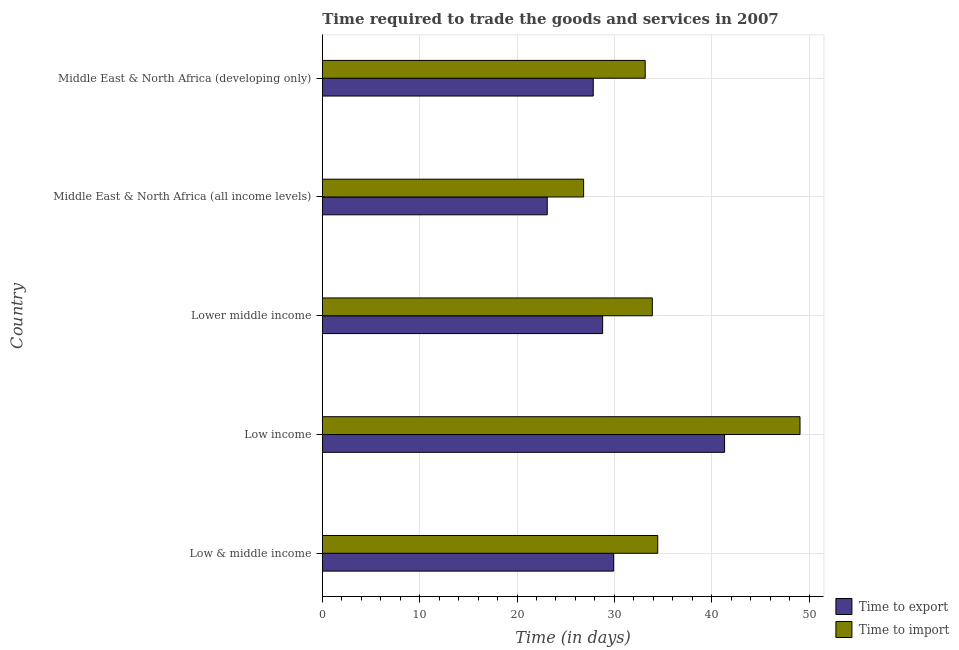How many different coloured bars are there?
Provide a succinct answer. 2. How many groups of bars are there?
Give a very brief answer. 5. Are the number of bars per tick equal to the number of legend labels?
Your response must be concise. Yes. Are the number of bars on each tick of the Y-axis equal?
Your answer should be compact. Yes. How many bars are there on the 3rd tick from the top?
Offer a very short reply. 2. How many bars are there on the 2nd tick from the bottom?
Keep it short and to the point. 2. What is the label of the 1st group of bars from the top?
Offer a terse response. Middle East & North Africa (developing only). What is the time to export in Middle East & North Africa (all income levels)?
Offer a very short reply. 23.11. Across all countries, what is the maximum time to export?
Make the answer very short. 41.32. Across all countries, what is the minimum time to import?
Provide a short and direct response. 26.84. In which country was the time to import maximum?
Offer a terse response. Low income. In which country was the time to export minimum?
Your response must be concise. Middle East & North Africa (all income levels). What is the total time to import in the graph?
Provide a succinct answer. 177.43. What is the difference between the time to import in Middle East & North Africa (all income levels) and that in Middle East & North Africa (developing only)?
Your response must be concise. -6.33. What is the difference between the time to import in Low income and the time to export in Middle East & North Africa (developing only)?
Provide a succinct answer. 21.24. What is the average time to import per country?
Make the answer very short. 35.49. What is the difference between the time to export and time to import in Lower middle income?
Offer a terse response. -5.1. In how many countries, is the time to export greater than 22 days?
Keep it short and to the point. 5. What is the ratio of the time to export in Low & middle income to that in Lower middle income?
Provide a succinct answer. 1.04. Is the difference between the time to export in Low & middle income and Middle East & North Africa (developing only) greater than the difference between the time to import in Low & middle income and Middle East & North Africa (developing only)?
Make the answer very short. Yes. What is the difference between the highest and the second highest time to export?
Offer a terse response. 11.39. What is the difference between the highest and the lowest time to export?
Ensure brevity in your answer.  18.22. Is the sum of the time to import in Low income and Middle East & North Africa (all income levels) greater than the maximum time to export across all countries?
Your answer should be compact. Yes. What does the 2nd bar from the top in Low income represents?
Provide a succinct answer. Time to export. What does the 2nd bar from the bottom in Low & middle income represents?
Offer a terse response. Time to import. How many bars are there?
Offer a very short reply. 10. Are all the bars in the graph horizontal?
Make the answer very short. Yes. What is the difference between two consecutive major ticks on the X-axis?
Offer a very short reply. 10. Does the graph contain any zero values?
Offer a terse response. No. Does the graph contain grids?
Your response must be concise. Yes. Where does the legend appear in the graph?
Offer a terse response. Bottom right. How many legend labels are there?
Your answer should be very brief. 2. What is the title of the graph?
Provide a short and direct response. Time required to trade the goods and services in 2007. Does "Commercial service exports" appear as one of the legend labels in the graph?
Keep it short and to the point. No. What is the label or title of the X-axis?
Provide a succinct answer. Time (in days). What is the label or title of the Y-axis?
Your response must be concise. Country. What is the Time (in days) in Time to export in Low & middle income?
Provide a short and direct response. 29.93. What is the Time (in days) of Time to import in Low & middle income?
Provide a succinct answer. 34.46. What is the Time (in days) of Time to export in Low income?
Your answer should be compact. 41.32. What is the Time (in days) in Time to import in Low income?
Offer a terse response. 49.07. What is the Time (in days) in Time to export in Lower middle income?
Your answer should be compact. 28.8. What is the Time (in days) in Time to import in Lower middle income?
Provide a succinct answer. 33.9. What is the Time (in days) of Time to export in Middle East & North Africa (all income levels)?
Offer a very short reply. 23.11. What is the Time (in days) in Time to import in Middle East & North Africa (all income levels)?
Keep it short and to the point. 26.84. What is the Time (in days) in Time to export in Middle East & North Africa (developing only)?
Offer a terse response. 27.83. What is the Time (in days) in Time to import in Middle East & North Africa (developing only)?
Your response must be concise. 33.17. Across all countries, what is the maximum Time (in days) of Time to export?
Your answer should be very brief. 41.32. Across all countries, what is the maximum Time (in days) of Time to import?
Give a very brief answer. 49.07. Across all countries, what is the minimum Time (in days) in Time to export?
Offer a very short reply. 23.11. Across all countries, what is the minimum Time (in days) of Time to import?
Your response must be concise. 26.84. What is the total Time (in days) in Time to export in the graph?
Provide a short and direct response. 150.98. What is the total Time (in days) of Time to import in the graph?
Your response must be concise. 177.43. What is the difference between the Time (in days) of Time to export in Low & middle income and that in Low income?
Give a very brief answer. -11.39. What is the difference between the Time (in days) in Time to import in Low & middle income and that in Low income?
Provide a short and direct response. -14.62. What is the difference between the Time (in days) in Time to export in Low & middle income and that in Lower middle income?
Offer a terse response. 1.13. What is the difference between the Time (in days) in Time to import in Low & middle income and that in Lower middle income?
Keep it short and to the point. 0.56. What is the difference between the Time (in days) of Time to export in Low & middle income and that in Middle East & North Africa (all income levels)?
Ensure brevity in your answer.  6.82. What is the difference between the Time (in days) in Time to import in Low & middle income and that in Middle East & North Africa (all income levels)?
Provide a short and direct response. 7.61. What is the difference between the Time (in days) of Time to export in Low & middle income and that in Middle East & North Africa (developing only)?
Give a very brief answer. 2.09. What is the difference between the Time (in days) of Time to import in Low & middle income and that in Middle East & North Africa (developing only)?
Your answer should be very brief. 1.29. What is the difference between the Time (in days) of Time to export in Low income and that in Lower middle income?
Ensure brevity in your answer.  12.53. What is the difference between the Time (in days) of Time to import in Low income and that in Lower middle income?
Keep it short and to the point. 15.17. What is the difference between the Time (in days) in Time to export in Low income and that in Middle East & North Africa (all income levels)?
Offer a terse response. 18.22. What is the difference between the Time (in days) of Time to import in Low income and that in Middle East & North Africa (all income levels)?
Your answer should be compact. 22.23. What is the difference between the Time (in days) in Time to export in Low income and that in Middle East & North Africa (developing only)?
Make the answer very short. 13.49. What is the difference between the Time (in days) in Time to import in Low income and that in Middle East & North Africa (developing only)?
Your response must be concise. 15.9. What is the difference between the Time (in days) in Time to export in Lower middle income and that in Middle East & North Africa (all income levels)?
Provide a short and direct response. 5.69. What is the difference between the Time (in days) in Time to import in Lower middle income and that in Middle East & North Africa (all income levels)?
Give a very brief answer. 7.06. What is the difference between the Time (in days) in Time to export in Lower middle income and that in Middle East & North Africa (developing only)?
Your response must be concise. 0.96. What is the difference between the Time (in days) of Time to import in Lower middle income and that in Middle East & North Africa (developing only)?
Your answer should be very brief. 0.73. What is the difference between the Time (in days) in Time to export in Middle East & North Africa (all income levels) and that in Middle East & North Africa (developing only)?
Provide a short and direct response. -4.73. What is the difference between the Time (in days) of Time to import in Middle East & North Africa (all income levels) and that in Middle East & North Africa (developing only)?
Make the answer very short. -6.32. What is the difference between the Time (in days) in Time to export in Low & middle income and the Time (in days) in Time to import in Low income?
Your answer should be very brief. -19.14. What is the difference between the Time (in days) in Time to export in Low & middle income and the Time (in days) in Time to import in Lower middle income?
Provide a short and direct response. -3.97. What is the difference between the Time (in days) in Time to export in Low & middle income and the Time (in days) in Time to import in Middle East & North Africa (all income levels)?
Provide a short and direct response. 3.09. What is the difference between the Time (in days) of Time to export in Low & middle income and the Time (in days) of Time to import in Middle East & North Africa (developing only)?
Give a very brief answer. -3.24. What is the difference between the Time (in days) of Time to export in Low income and the Time (in days) of Time to import in Lower middle income?
Make the answer very short. 7.42. What is the difference between the Time (in days) of Time to export in Low income and the Time (in days) of Time to import in Middle East & North Africa (all income levels)?
Provide a succinct answer. 14.48. What is the difference between the Time (in days) of Time to export in Low income and the Time (in days) of Time to import in Middle East & North Africa (developing only)?
Offer a very short reply. 8.15. What is the difference between the Time (in days) in Time to export in Lower middle income and the Time (in days) in Time to import in Middle East & North Africa (all income levels)?
Make the answer very short. 1.95. What is the difference between the Time (in days) in Time to export in Lower middle income and the Time (in days) in Time to import in Middle East & North Africa (developing only)?
Your answer should be very brief. -4.37. What is the difference between the Time (in days) of Time to export in Middle East & North Africa (all income levels) and the Time (in days) of Time to import in Middle East & North Africa (developing only)?
Your answer should be very brief. -10.06. What is the average Time (in days) of Time to export per country?
Give a very brief answer. 30.2. What is the average Time (in days) of Time to import per country?
Provide a succinct answer. 35.49. What is the difference between the Time (in days) in Time to export and Time (in days) in Time to import in Low & middle income?
Keep it short and to the point. -4.53. What is the difference between the Time (in days) in Time to export and Time (in days) in Time to import in Low income?
Give a very brief answer. -7.75. What is the difference between the Time (in days) in Time to export and Time (in days) in Time to import in Lower middle income?
Provide a short and direct response. -5.1. What is the difference between the Time (in days) of Time to export and Time (in days) of Time to import in Middle East & North Africa (all income levels)?
Your answer should be very brief. -3.74. What is the difference between the Time (in days) in Time to export and Time (in days) in Time to import in Middle East & North Africa (developing only)?
Your answer should be very brief. -5.33. What is the ratio of the Time (in days) of Time to export in Low & middle income to that in Low income?
Provide a short and direct response. 0.72. What is the ratio of the Time (in days) in Time to import in Low & middle income to that in Low income?
Ensure brevity in your answer.  0.7. What is the ratio of the Time (in days) in Time to export in Low & middle income to that in Lower middle income?
Your answer should be very brief. 1.04. What is the ratio of the Time (in days) of Time to import in Low & middle income to that in Lower middle income?
Provide a short and direct response. 1.02. What is the ratio of the Time (in days) in Time to export in Low & middle income to that in Middle East & North Africa (all income levels)?
Make the answer very short. 1.3. What is the ratio of the Time (in days) of Time to import in Low & middle income to that in Middle East & North Africa (all income levels)?
Make the answer very short. 1.28. What is the ratio of the Time (in days) in Time to export in Low & middle income to that in Middle East & North Africa (developing only)?
Offer a terse response. 1.08. What is the ratio of the Time (in days) of Time to import in Low & middle income to that in Middle East & North Africa (developing only)?
Your response must be concise. 1.04. What is the ratio of the Time (in days) of Time to export in Low income to that in Lower middle income?
Make the answer very short. 1.44. What is the ratio of the Time (in days) of Time to import in Low income to that in Lower middle income?
Give a very brief answer. 1.45. What is the ratio of the Time (in days) in Time to export in Low income to that in Middle East & North Africa (all income levels)?
Ensure brevity in your answer.  1.79. What is the ratio of the Time (in days) in Time to import in Low income to that in Middle East & North Africa (all income levels)?
Provide a succinct answer. 1.83. What is the ratio of the Time (in days) in Time to export in Low income to that in Middle East & North Africa (developing only)?
Offer a terse response. 1.48. What is the ratio of the Time (in days) of Time to import in Low income to that in Middle East & North Africa (developing only)?
Keep it short and to the point. 1.48. What is the ratio of the Time (in days) in Time to export in Lower middle income to that in Middle East & North Africa (all income levels)?
Keep it short and to the point. 1.25. What is the ratio of the Time (in days) of Time to import in Lower middle income to that in Middle East & North Africa (all income levels)?
Your response must be concise. 1.26. What is the ratio of the Time (in days) of Time to export in Lower middle income to that in Middle East & North Africa (developing only)?
Provide a succinct answer. 1.03. What is the ratio of the Time (in days) in Time to export in Middle East & North Africa (all income levels) to that in Middle East & North Africa (developing only)?
Make the answer very short. 0.83. What is the ratio of the Time (in days) in Time to import in Middle East & North Africa (all income levels) to that in Middle East & North Africa (developing only)?
Give a very brief answer. 0.81. What is the difference between the highest and the second highest Time (in days) in Time to export?
Your answer should be compact. 11.39. What is the difference between the highest and the second highest Time (in days) in Time to import?
Provide a short and direct response. 14.62. What is the difference between the highest and the lowest Time (in days) of Time to export?
Provide a succinct answer. 18.22. What is the difference between the highest and the lowest Time (in days) in Time to import?
Offer a terse response. 22.23. 